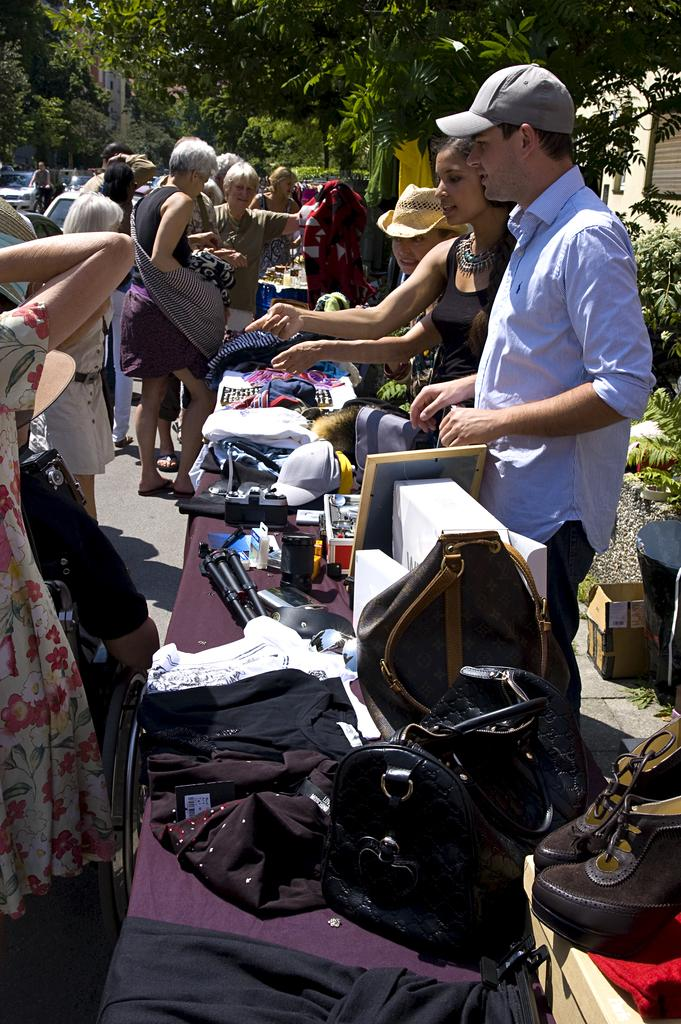How many people are in the group that is visible in the image? There is a group of people standing in the image, but the exact number cannot be determined from the provided facts. What is on the table that is visible in the image? There is a table with objects on it in the image, but the specific objects cannot be identified from the provided facts. What type of vegetation is visible in the image? There are green trees visible in the image. How many spoons are in the bath in the image? There is no bath or spoons present in the image. 